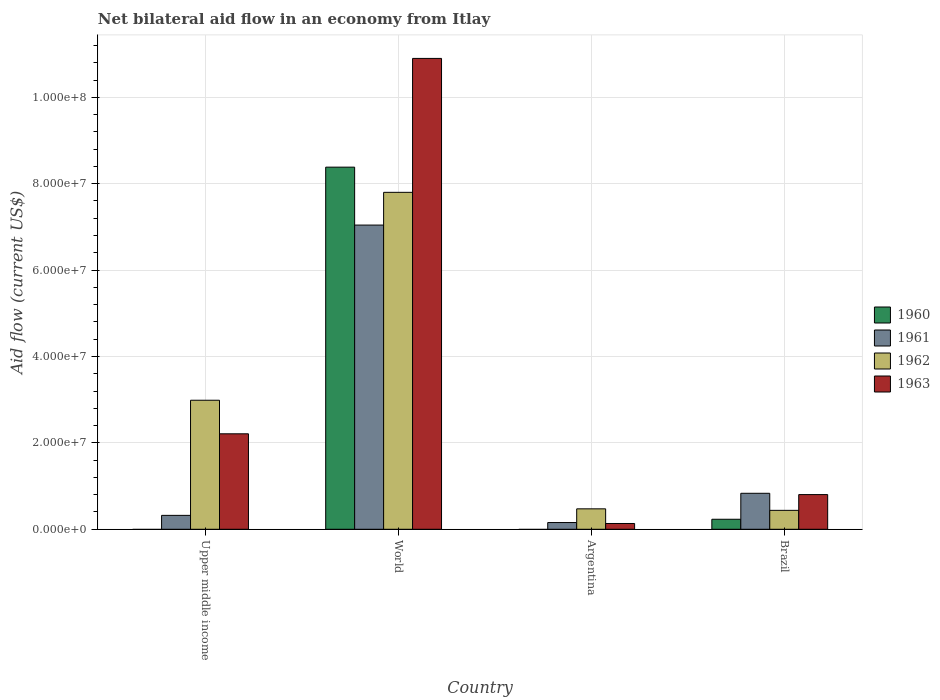How many different coloured bars are there?
Give a very brief answer. 4. Are the number of bars per tick equal to the number of legend labels?
Make the answer very short. No. Are the number of bars on each tick of the X-axis equal?
Ensure brevity in your answer.  No. How many bars are there on the 1st tick from the left?
Make the answer very short. 3. What is the net bilateral aid flow in 1962 in World?
Offer a terse response. 7.80e+07. Across all countries, what is the maximum net bilateral aid flow in 1962?
Make the answer very short. 7.80e+07. Across all countries, what is the minimum net bilateral aid flow in 1962?
Provide a short and direct response. 4.38e+06. In which country was the net bilateral aid flow in 1962 maximum?
Provide a succinct answer. World. What is the total net bilateral aid flow in 1962 in the graph?
Provide a short and direct response. 1.17e+08. What is the difference between the net bilateral aid flow in 1963 in Upper middle income and that in World?
Provide a short and direct response. -8.69e+07. What is the difference between the net bilateral aid flow in 1960 in World and the net bilateral aid flow in 1962 in Brazil?
Make the answer very short. 7.94e+07. What is the average net bilateral aid flow in 1960 per country?
Make the answer very short. 2.15e+07. What is the difference between the net bilateral aid flow of/in 1962 and net bilateral aid flow of/in 1961 in Upper middle income?
Your response must be concise. 2.66e+07. In how many countries, is the net bilateral aid flow in 1961 greater than 8000000 US$?
Offer a terse response. 2. What is the ratio of the net bilateral aid flow in 1961 in Argentina to that in World?
Your answer should be very brief. 0.02. Is the net bilateral aid flow in 1960 in Brazil less than that in World?
Offer a very short reply. Yes. What is the difference between the highest and the second highest net bilateral aid flow in 1961?
Offer a very short reply. 6.21e+07. What is the difference between the highest and the lowest net bilateral aid flow in 1960?
Provide a succinct answer. 8.38e+07. In how many countries, is the net bilateral aid flow in 1961 greater than the average net bilateral aid flow in 1961 taken over all countries?
Your answer should be compact. 1. Is the sum of the net bilateral aid flow in 1962 in Argentina and World greater than the maximum net bilateral aid flow in 1961 across all countries?
Make the answer very short. Yes. Is it the case that in every country, the sum of the net bilateral aid flow in 1962 and net bilateral aid flow in 1961 is greater than the net bilateral aid flow in 1963?
Offer a very short reply. Yes. How many bars are there?
Your answer should be compact. 14. How many countries are there in the graph?
Make the answer very short. 4. What is the difference between two consecutive major ticks on the Y-axis?
Make the answer very short. 2.00e+07. Are the values on the major ticks of Y-axis written in scientific E-notation?
Provide a succinct answer. Yes. What is the title of the graph?
Your answer should be very brief. Net bilateral aid flow in an economy from Itlay. What is the label or title of the X-axis?
Offer a very short reply. Country. What is the Aid flow (current US$) of 1960 in Upper middle income?
Provide a short and direct response. 0. What is the Aid flow (current US$) in 1961 in Upper middle income?
Your response must be concise. 3.22e+06. What is the Aid flow (current US$) of 1962 in Upper middle income?
Your answer should be compact. 2.99e+07. What is the Aid flow (current US$) in 1963 in Upper middle income?
Offer a terse response. 2.21e+07. What is the Aid flow (current US$) of 1960 in World?
Keep it short and to the point. 8.38e+07. What is the Aid flow (current US$) in 1961 in World?
Provide a short and direct response. 7.04e+07. What is the Aid flow (current US$) in 1962 in World?
Keep it short and to the point. 7.80e+07. What is the Aid flow (current US$) in 1963 in World?
Your response must be concise. 1.09e+08. What is the Aid flow (current US$) in 1960 in Argentina?
Provide a short and direct response. 0. What is the Aid flow (current US$) of 1961 in Argentina?
Provide a short and direct response. 1.56e+06. What is the Aid flow (current US$) in 1962 in Argentina?
Provide a short and direct response. 4.73e+06. What is the Aid flow (current US$) of 1963 in Argentina?
Give a very brief answer. 1.34e+06. What is the Aid flow (current US$) in 1960 in Brazil?
Make the answer very short. 2.32e+06. What is the Aid flow (current US$) in 1961 in Brazil?
Offer a terse response. 8.33e+06. What is the Aid flow (current US$) of 1962 in Brazil?
Your answer should be very brief. 4.38e+06. What is the Aid flow (current US$) of 1963 in Brazil?
Provide a succinct answer. 8.03e+06. Across all countries, what is the maximum Aid flow (current US$) of 1960?
Your answer should be very brief. 8.38e+07. Across all countries, what is the maximum Aid flow (current US$) in 1961?
Make the answer very short. 7.04e+07. Across all countries, what is the maximum Aid flow (current US$) of 1962?
Provide a succinct answer. 7.80e+07. Across all countries, what is the maximum Aid flow (current US$) of 1963?
Ensure brevity in your answer.  1.09e+08. Across all countries, what is the minimum Aid flow (current US$) of 1961?
Provide a short and direct response. 1.56e+06. Across all countries, what is the minimum Aid flow (current US$) of 1962?
Your answer should be compact. 4.38e+06. Across all countries, what is the minimum Aid flow (current US$) in 1963?
Keep it short and to the point. 1.34e+06. What is the total Aid flow (current US$) of 1960 in the graph?
Ensure brevity in your answer.  8.62e+07. What is the total Aid flow (current US$) in 1961 in the graph?
Offer a very short reply. 8.35e+07. What is the total Aid flow (current US$) of 1962 in the graph?
Your answer should be very brief. 1.17e+08. What is the total Aid flow (current US$) in 1963 in the graph?
Provide a short and direct response. 1.40e+08. What is the difference between the Aid flow (current US$) of 1961 in Upper middle income and that in World?
Give a very brief answer. -6.72e+07. What is the difference between the Aid flow (current US$) of 1962 in Upper middle income and that in World?
Give a very brief answer. -4.81e+07. What is the difference between the Aid flow (current US$) of 1963 in Upper middle income and that in World?
Provide a short and direct response. -8.69e+07. What is the difference between the Aid flow (current US$) of 1961 in Upper middle income and that in Argentina?
Offer a terse response. 1.66e+06. What is the difference between the Aid flow (current US$) in 1962 in Upper middle income and that in Argentina?
Your response must be concise. 2.51e+07. What is the difference between the Aid flow (current US$) in 1963 in Upper middle income and that in Argentina?
Ensure brevity in your answer.  2.08e+07. What is the difference between the Aid flow (current US$) of 1961 in Upper middle income and that in Brazil?
Keep it short and to the point. -5.11e+06. What is the difference between the Aid flow (current US$) in 1962 in Upper middle income and that in Brazil?
Provide a succinct answer. 2.55e+07. What is the difference between the Aid flow (current US$) in 1963 in Upper middle income and that in Brazil?
Make the answer very short. 1.41e+07. What is the difference between the Aid flow (current US$) in 1961 in World and that in Argentina?
Keep it short and to the point. 6.89e+07. What is the difference between the Aid flow (current US$) in 1962 in World and that in Argentina?
Give a very brief answer. 7.33e+07. What is the difference between the Aid flow (current US$) of 1963 in World and that in Argentina?
Provide a short and direct response. 1.08e+08. What is the difference between the Aid flow (current US$) of 1960 in World and that in Brazil?
Offer a very short reply. 8.15e+07. What is the difference between the Aid flow (current US$) of 1961 in World and that in Brazil?
Your answer should be very brief. 6.21e+07. What is the difference between the Aid flow (current US$) in 1962 in World and that in Brazil?
Keep it short and to the point. 7.36e+07. What is the difference between the Aid flow (current US$) of 1963 in World and that in Brazil?
Offer a very short reply. 1.01e+08. What is the difference between the Aid flow (current US$) in 1961 in Argentina and that in Brazil?
Offer a terse response. -6.77e+06. What is the difference between the Aid flow (current US$) of 1962 in Argentina and that in Brazil?
Give a very brief answer. 3.50e+05. What is the difference between the Aid flow (current US$) of 1963 in Argentina and that in Brazil?
Keep it short and to the point. -6.69e+06. What is the difference between the Aid flow (current US$) of 1961 in Upper middle income and the Aid flow (current US$) of 1962 in World?
Your answer should be compact. -7.48e+07. What is the difference between the Aid flow (current US$) in 1961 in Upper middle income and the Aid flow (current US$) in 1963 in World?
Offer a terse response. -1.06e+08. What is the difference between the Aid flow (current US$) in 1962 in Upper middle income and the Aid flow (current US$) in 1963 in World?
Keep it short and to the point. -7.91e+07. What is the difference between the Aid flow (current US$) of 1961 in Upper middle income and the Aid flow (current US$) of 1962 in Argentina?
Provide a succinct answer. -1.51e+06. What is the difference between the Aid flow (current US$) of 1961 in Upper middle income and the Aid flow (current US$) of 1963 in Argentina?
Keep it short and to the point. 1.88e+06. What is the difference between the Aid flow (current US$) of 1962 in Upper middle income and the Aid flow (current US$) of 1963 in Argentina?
Offer a terse response. 2.85e+07. What is the difference between the Aid flow (current US$) in 1961 in Upper middle income and the Aid flow (current US$) in 1962 in Brazil?
Give a very brief answer. -1.16e+06. What is the difference between the Aid flow (current US$) of 1961 in Upper middle income and the Aid flow (current US$) of 1963 in Brazil?
Offer a terse response. -4.81e+06. What is the difference between the Aid flow (current US$) in 1962 in Upper middle income and the Aid flow (current US$) in 1963 in Brazil?
Offer a very short reply. 2.18e+07. What is the difference between the Aid flow (current US$) of 1960 in World and the Aid flow (current US$) of 1961 in Argentina?
Keep it short and to the point. 8.23e+07. What is the difference between the Aid flow (current US$) of 1960 in World and the Aid flow (current US$) of 1962 in Argentina?
Give a very brief answer. 7.91e+07. What is the difference between the Aid flow (current US$) in 1960 in World and the Aid flow (current US$) in 1963 in Argentina?
Make the answer very short. 8.25e+07. What is the difference between the Aid flow (current US$) of 1961 in World and the Aid flow (current US$) of 1962 in Argentina?
Offer a terse response. 6.57e+07. What is the difference between the Aid flow (current US$) in 1961 in World and the Aid flow (current US$) in 1963 in Argentina?
Your response must be concise. 6.91e+07. What is the difference between the Aid flow (current US$) of 1962 in World and the Aid flow (current US$) of 1963 in Argentina?
Keep it short and to the point. 7.67e+07. What is the difference between the Aid flow (current US$) of 1960 in World and the Aid flow (current US$) of 1961 in Brazil?
Offer a terse response. 7.55e+07. What is the difference between the Aid flow (current US$) in 1960 in World and the Aid flow (current US$) in 1962 in Brazil?
Ensure brevity in your answer.  7.94e+07. What is the difference between the Aid flow (current US$) of 1960 in World and the Aid flow (current US$) of 1963 in Brazil?
Provide a short and direct response. 7.58e+07. What is the difference between the Aid flow (current US$) in 1961 in World and the Aid flow (current US$) in 1962 in Brazil?
Provide a short and direct response. 6.60e+07. What is the difference between the Aid flow (current US$) in 1961 in World and the Aid flow (current US$) in 1963 in Brazil?
Your response must be concise. 6.24e+07. What is the difference between the Aid flow (current US$) of 1962 in World and the Aid flow (current US$) of 1963 in Brazil?
Offer a terse response. 7.00e+07. What is the difference between the Aid flow (current US$) in 1961 in Argentina and the Aid flow (current US$) in 1962 in Brazil?
Offer a terse response. -2.82e+06. What is the difference between the Aid flow (current US$) in 1961 in Argentina and the Aid flow (current US$) in 1963 in Brazil?
Your answer should be compact. -6.47e+06. What is the difference between the Aid flow (current US$) of 1962 in Argentina and the Aid flow (current US$) of 1963 in Brazil?
Offer a very short reply. -3.30e+06. What is the average Aid flow (current US$) of 1960 per country?
Your answer should be compact. 2.15e+07. What is the average Aid flow (current US$) in 1961 per country?
Keep it short and to the point. 2.09e+07. What is the average Aid flow (current US$) of 1962 per country?
Your response must be concise. 2.92e+07. What is the average Aid flow (current US$) in 1963 per country?
Offer a very short reply. 3.51e+07. What is the difference between the Aid flow (current US$) of 1961 and Aid flow (current US$) of 1962 in Upper middle income?
Offer a terse response. -2.66e+07. What is the difference between the Aid flow (current US$) of 1961 and Aid flow (current US$) of 1963 in Upper middle income?
Provide a short and direct response. -1.89e+07. What is the difference between the Aid flow (current US$) in 1962 and Aid flow (current US$) in 1963 in Upper middle income?
Give a very brief answer. 7.77e+06. What is the difference between the Aid flow (current US$) of 1960 and Aid flow (current US$) of 1961 in World?
Your answer should be compact. 1.34e+07. What is the difference between the Aid flow (current US$) in 1960 and Aid flow (current US$) in 1962 in World?
Make the answer very short. 5.83e+06. What is the difference between the Aid flow (current US$) in 1960 and Aid flow (current US$) in 1963 in World?
Your answer should be compact. -2.52e+07. What is the difference between the Aid flow (current US$) in 1961 and Aid flow (current US$) in 1962 in World?
Provide a succinct answer. -7.58e+06. What is the difference between the Aid flow (current US$) of 1961 and Aid flow (current US$) of 1963 in World?
Offer a very short reply. -3.86e+07. What is the difference between the Aid flow (current US$) of 1962 and Aid flow (current US$) of 1963 in World?
Provide a succinct answer. -3.10e+07. What is the difference between the Aid flow (current US$) in 1961 and Aid flow (current US$) in 1962 in Argentina?
Your answer should be compact. -3.17e+06. What is the difference between the Aid flow (current US$) in 1962 and Aid flow (current US$) in 1963 in Argentina?
Ensure brevity in your answer.  3.39e+06. What is the difference between the Aid flow (current US$) of 1960 and Aid flow (current US$) of 1961 in Brazil?
Your response must be concise. -6.01e+06. What is the difference between the Aid flow (current US$) in 1960 and Aid flow (current US$) in 1962 in Brazil?
Your response must be concise. -2.06e+06. What is the difference between the Aid flow (current US$) in 1960 and Aid flow (current US$) in 1963 in Brazil?
Your response must be concise. -5.71e+06. What is the difference between the Aid flow (current US$) in 1961 and Aid flow (current US$) in 1962 in Brazil?
Ensure brevity in your answer.  3.95e+06. What is the difference between the Aid flow (current US$) in 1961 and Aid flow (current US$) in 1963 in Brazil?
Offer a very short reply. 3.00e+05. What is the difference between the Aid flow (current US$) in 1962 and Aid flow (current US$) in 1963 in Brazil?
Offer a very short reply. -3.65e+06. What is the ratio of the Aid flow (current US$) of 1961 in Upper middle income to that in World?
Keep it short and to the point. 0.05. What is the ratio of the Aid flow (current US$) of 1962 in Upper middle income to that in World?
Keep it short and to the point. 0.38. What is the ratio of the Aid flow (current US$) of 1963 in Upper middle income to that in World?
Make the answer very short. 0.2. What is the ratio of the Aid flow (current US$) of 1961 in Upper middle income to that in Argentina?
Provide a succinct answer. 2.06. What is the ratio of the Aid flow (current US$) in 1962 in Upper middle income to that in Argentina?
Your response must be concise. 6.32. What is the ratio of the Aid flow (current US$) in 1963 in Upper middle income to that in Argentina?
Your answer should be very brief. 16.49. What is the ratio of the Aid flow (current US$) in 1961 in Upper middle income to that in Brazil?
Provide a short and direct response. 0.39. What is the ratio of the Aid flow (current US$) of 1962 in Upper middle income to that in Brazil?
Your answer should be compact. 6.82. What is the ratio of the Aid flow (current US$) in 1963 in Upper middle income to that in Brazil?
Give a very brief answer. 2.75. What is the ratio of the Aid flow (current US$) in 1961 in World to that in Argentina?
Provide a short and direct response. 45.14. What is the ratio of the Aid flow (current US$) in 1962 in World to that in Argentina?
Provide a succinct answer. 16.49. What is the ratio of the Aid flow (current US$) of 1963 in World to that in Argentina?
Keep it short and to the point. 81.34. What is the ratio of the Aid flow (current US$) of 1960 in World to that in Brazil?
Ensure brevity in your answer.  36.13. What is the ratio of the Aid flow (current US$) in 1961 in World to that in Brazil?
Offer a very short reply. 8.45. What is the ratio of the Aid flow (current US$) in 1962 in World to that in Brazil?
Offer a very short reply. 17.81. What is the ratio of the Aid flow (current US$) in 1963 in World to that in Brazil?
Offer a terse response. 13.57. What is the ratio of the Aid flow (current US$) of 1961 in Argentina to that in Brazil?
Keep it short and to the point. 0.19. What is the ratio of the Aid flow (current US$) in 1962 in Argentina to that in Brazil?
Your answer should be compact. 1.08. What is the ratio of the Aid flow (current US$) in 1963 in Argentina to that in Brazil?
Make the answer very short. 0.17. What is the difference between the highest and the second highest Aid flow (current US$) of 1961?
Offer a terse response. 6.21e+07. What is the difference between the highest and the second highest Aid flow (current US$) in 1962?
Provide a succinct answer. 4.81e+07. What is the difference between the highest and the second highest Aid flow (current US$) in 1963?
Your response must be concise. 8.69e+07. What is the difference between the highest and the lowest Aid flow (current US$) of 1960?
Ensure brevity in your answer.  8.38e+07. What is the difference between the highest and the lowest Aid flow (current US$) in 1961?
Make the answer very short. 6.89e+07. What is the difference between the highest and the lowest Aid flow (current US$) in 1962?
Your answer should be very brief. 7.36e+07. What is the difference between the highest and the lowest Aid flow (current US$) in 1963?
Give a very brief answer. 1.08e+08. 